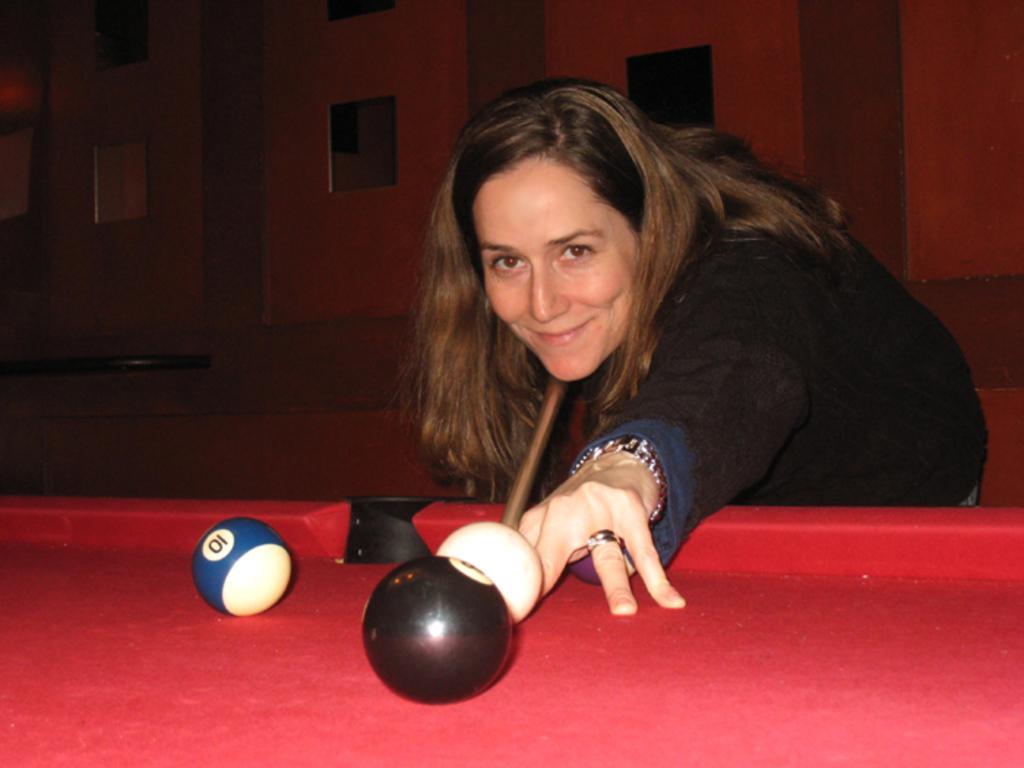Could you give a brief overview of what you see in this image? In this image in the front there is a table and on the table there are balls. In the background there is a woman standing and smiling and holding a stick in her hand. There is wall in the background. 